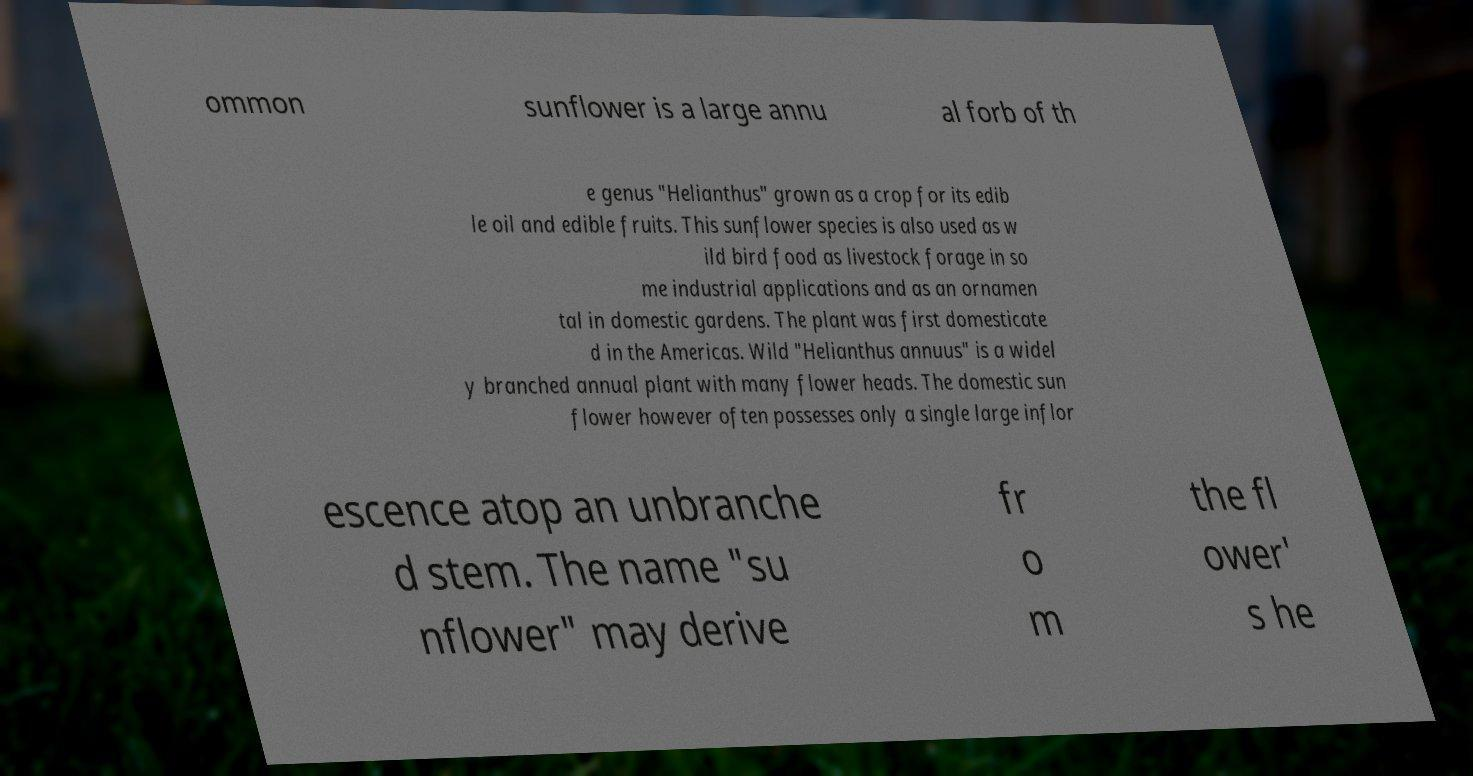There's text embedded in this image that I need extracted. Can you transcribe it verbatim? ommon sunflower is a large annu al forb of th e genus "Helianthus" grown as a crop for its edib le oil and edible fruits. This sunflower species is also used as w ild bird food as livestock forage in so me industrial applications and as an ornamen tal in domestic gardens. The plant was first domesticate d in the Americas. Wild "Helianthus annuus" is a widel y branched annual plant with many flower heads. The domestic sun flower however often possesses only a single large inflor escence atop an unbranche d stem. The name "su nflower" may derive fr o m the fl ower' s he 